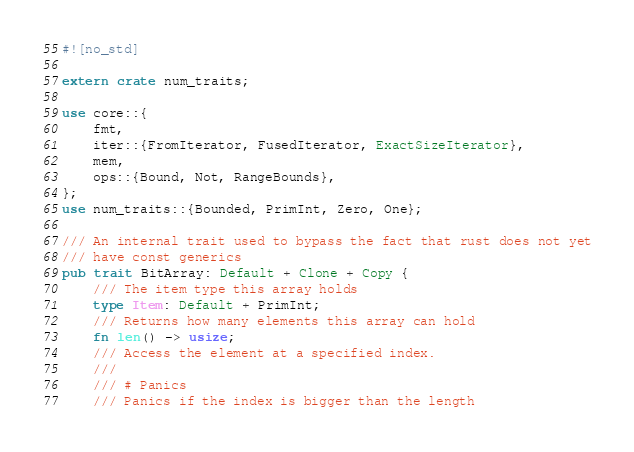Convert code to text. <code><loc_0><loc_0><loc_500><loc_500><_Rust_>#![no_std]

extern crate num_traits;

use core::{
    fmt,
    iter::{FromIterator, FusedIterator, ExactSizeIterator},
    mem,
    ops::{Bound, Not, RangeBounds},
};
use num_traits::{Bounded, PrimInt, Zero, One};

/// An internal trait used to bypass the fact that rust does not yet
/// have const generics
pub trait BitArray: Default + Clone + Copy {
    /// The item type this array holds
    type Item: Default + PrimInt;
    /// Returns how many elements this array can hold
    fn len() -> usize;
    /// Access the element at a specified index.
    ///
    /// # Panics
    /// Panics if the index is bigger than the length</code> 